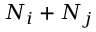Convert formula to latex. <formula><loc_0><loc_0><loc_500><loc_500>N _ { i } + N _ { j }</formula> 